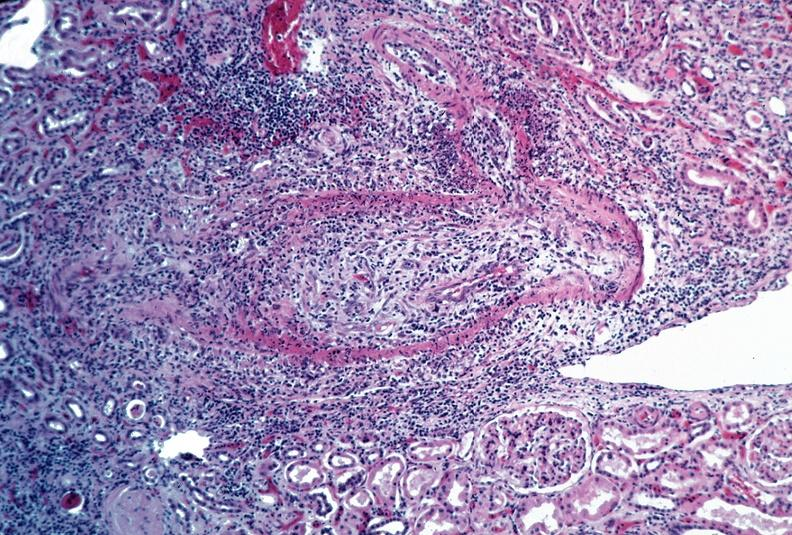what is present?
Answer the question using a single word or phrase. Cardiovascular 